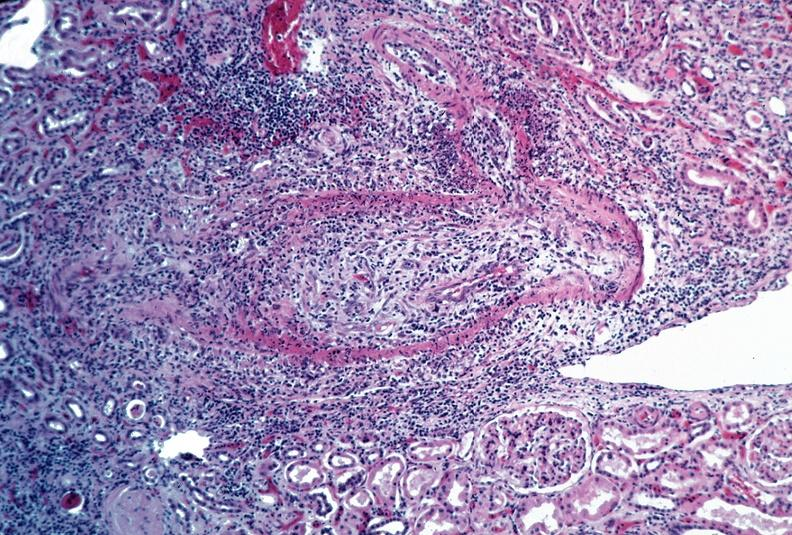what is present?
Answer the question using a single word or phrase. Cardiovascular 